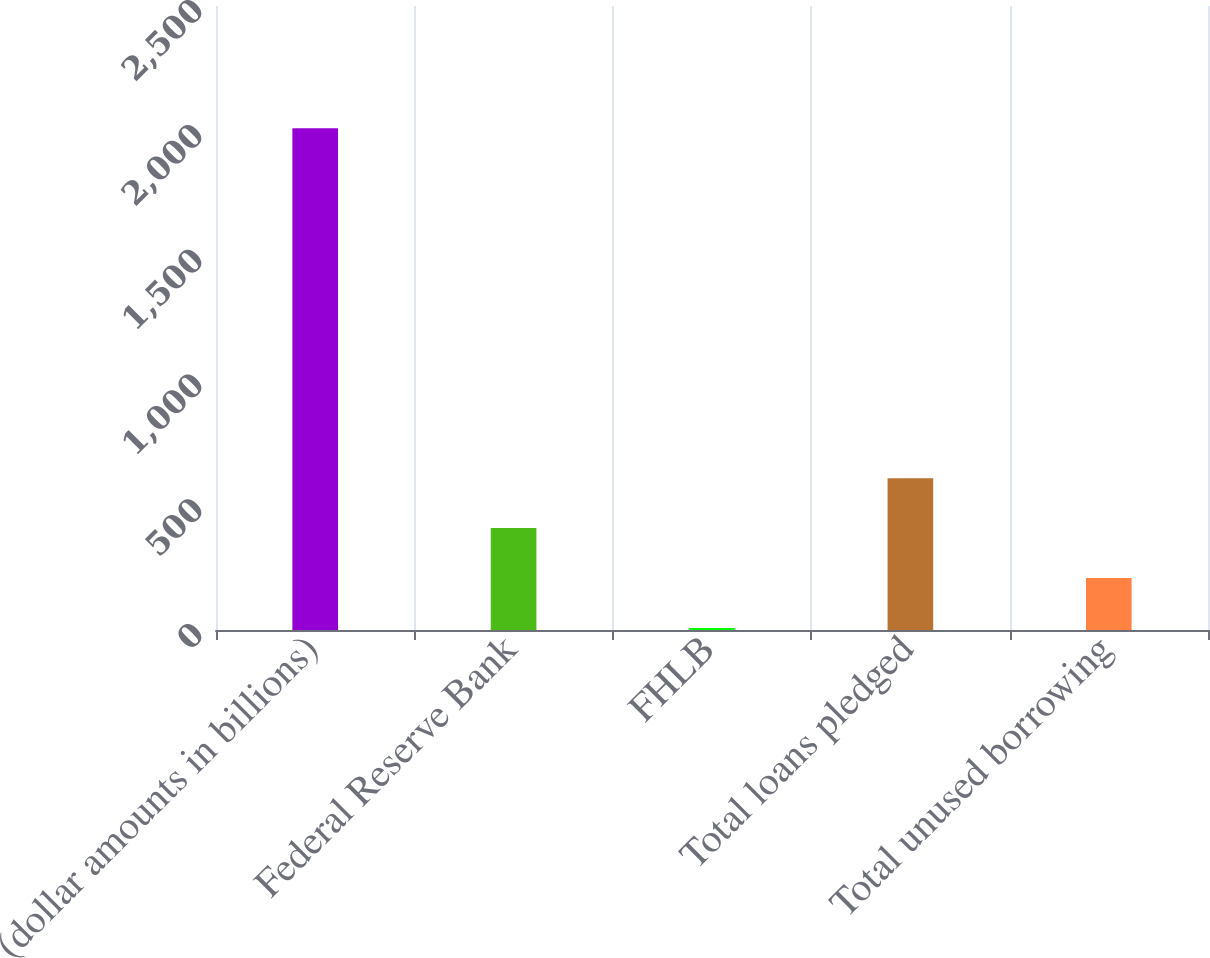<chart> <loc_0><loc_0><loc_500><loc_500><bar_chart><fcel>(dollar amounts in billions)<fcel>Federal Reserve Bank<fcel>FHLB<fcel>Total loans pledged<fcel>Total unused borrowing<nl><fcel>2010<fcel>408.24<fcel>7.8<fcel>608.46<fcel>208.02<nl></chart> 